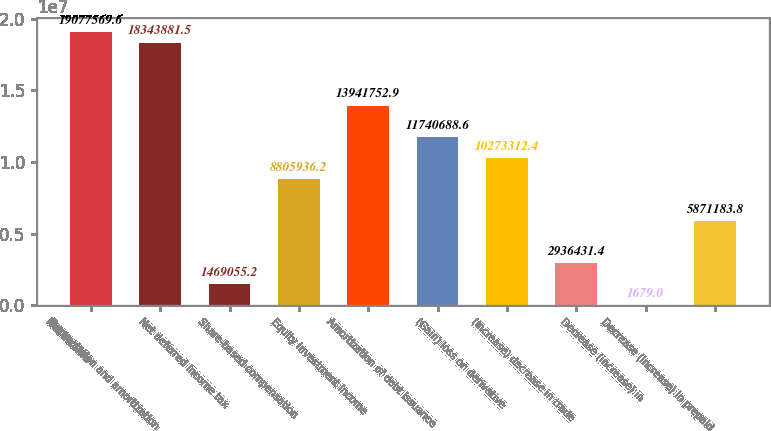Convert chart to OTSL. <chart><loc_0><loc_0><loc_500><loc_500><bar_chart><fcel>Net income<fcel>Depreciation and amortization<fcel>Net deferred income tax<fcel>Share-based compensation<fcel>Equity investment income<fcel>Amortization of debt issuance<fcel>(Gain) loss on derivative<fcel>(Increase) decrease in trade<fcel>Decrease (increase) in<fcel>Decrease (increase) in prepaid<nl><fcel>1.90776e+07<fcel>1.83439e+07<fcel>1.46906e+06<fcel>8.80594e+06<fcel>1.39418e+07<fcel>1.17407e+07<fcel>1.02733e+07<fcel>2.93643e+06<fcel>1679<fcel>5.87118e+06<nl></chart> 